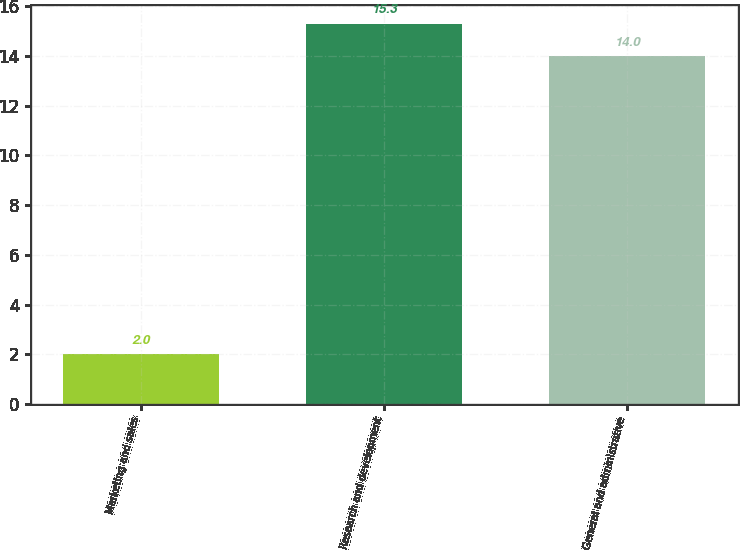<chart> <loc_0><loc_0><loc_500><loc_500><bar_chart><fcel>Marketing and sales<fcel>Research and development<fcel>General and administrative<nl><fcel>2<fcel>15.3<fcel>14<nl></chart> 